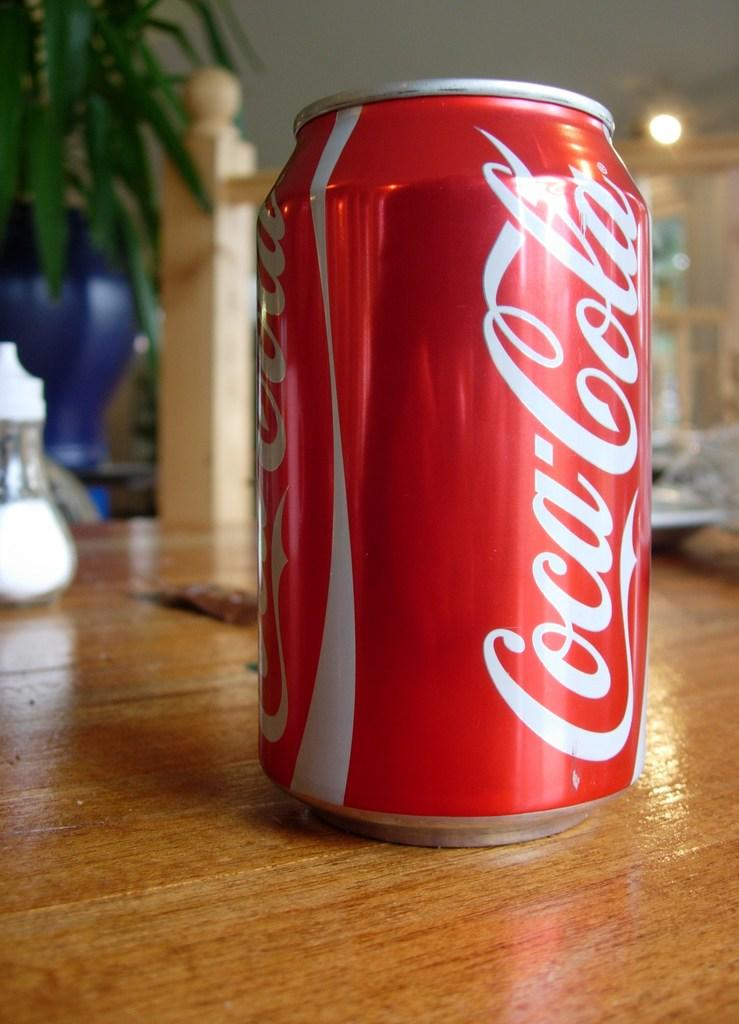<image>
Relay a brief, clear account of the picture shown. A can of Coca Cola sits on a wooden table. 